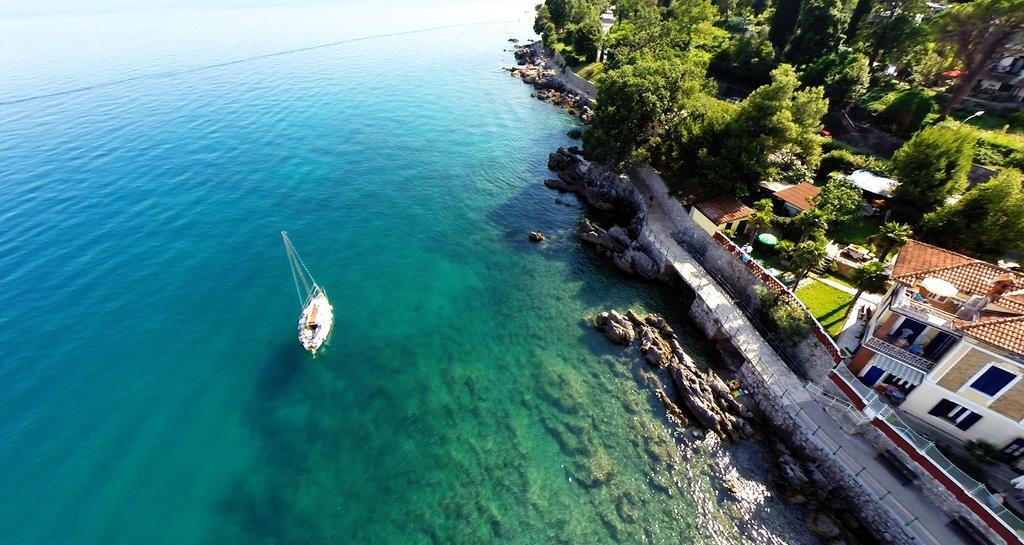How would you summarize this image in a sentence or two? In this image I can see water on the left side and on the water I can see a white colour boat. On the right side of this image I can see number of buildings, number of trees and on the bottom right side of this image I can see one person. 